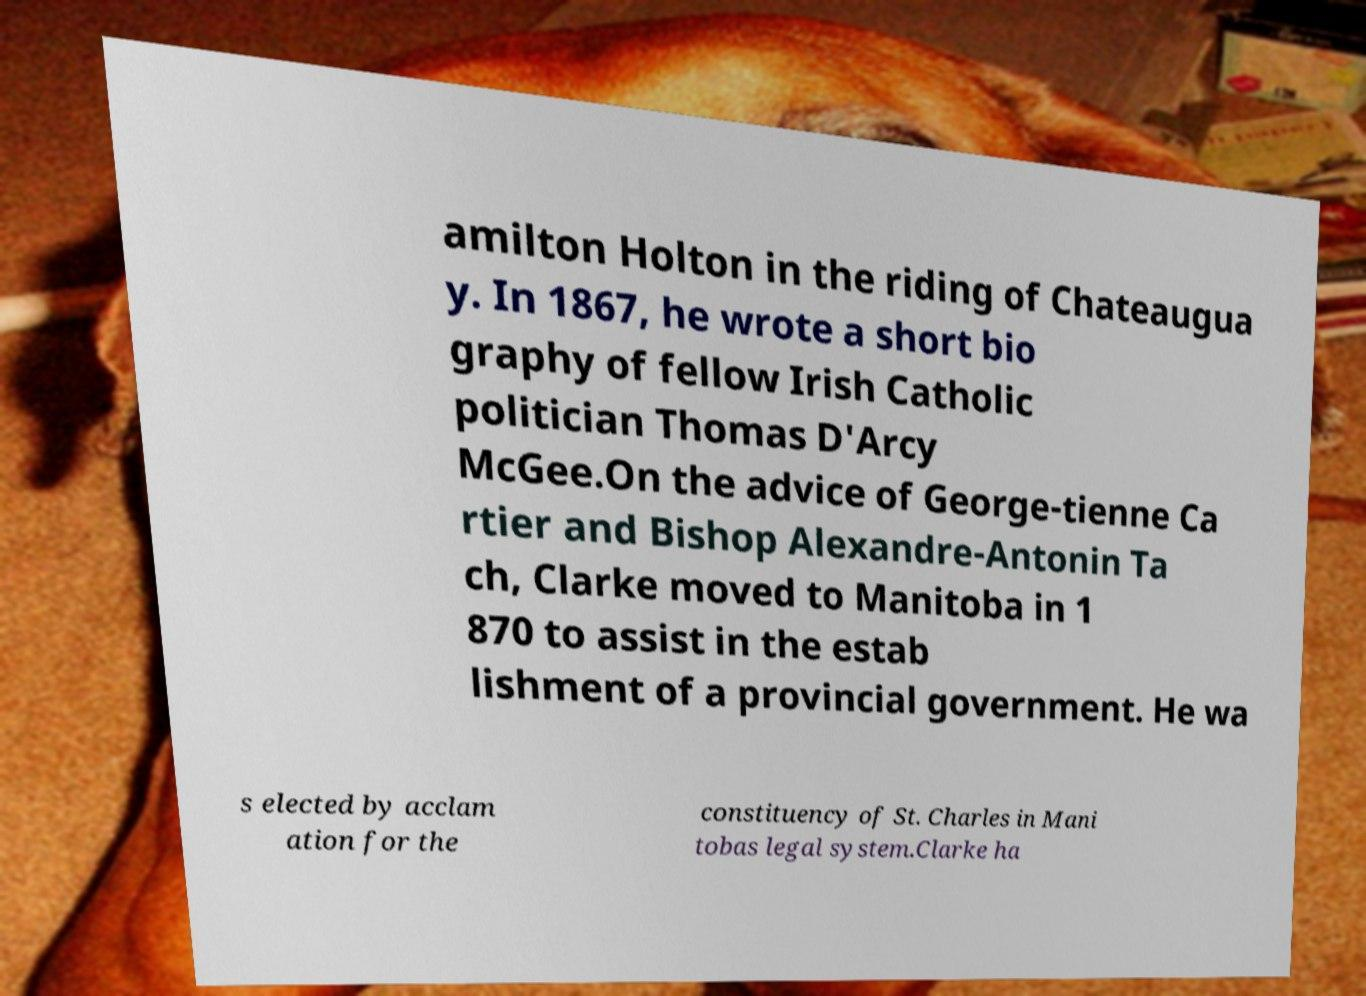For documentation purposes, I need the text within this image transcribed. Could you provide that? amilton Holton in the riding of Chateaugua y. In 1867, he wrote a short bio graphy of fellow Irish Catholic politician Thomas D'Arcy McGee.On the advice of George-tienne Ca rtier and Bishop Alexandre-Antonin Ta ch, Clarke moved to Manitoba in 1 870 to assist in the estab lishment of a provincial government. He wa s elected by acclam ation for the constituency of St. Charles in Mani tobas legal system.Clarke ha 